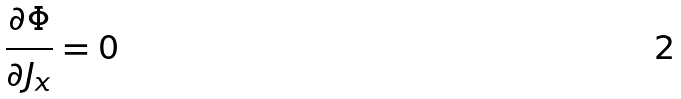<formula> <loc_0><loc_0><loc_500><loc_500>\frac { \partial \Phi } { \partial J _ { x } } = 0</formula> 